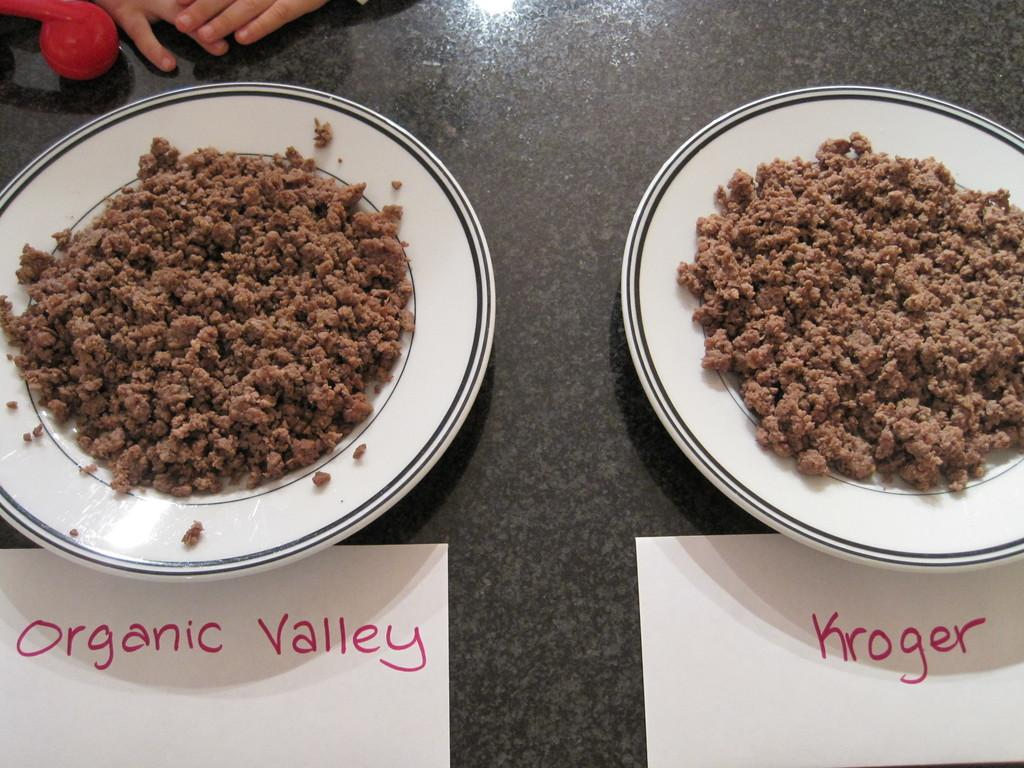What body part is visible in the image? Human fingers are visible in the image. How many plates can be seen in the image? There are two plates in the image. What is on the plates? There is food on the plates. What type of papers are present in the image? There are white papers with text in the image. What color is the surface in the image? There is a black surface in the image. What type of punishment is being discussed on the white papers in the image? There is no indication of punishment or any discussion on the white papers in the image; they contain text, but the content is not specified. 